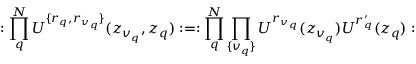Convert formula to latex. <formula><loc_0><loc_0><loc_500><loc_500>\colon \prod _ { q } ^ { N } U ^ { \{ r _ { q } , r _ { v _ { q } } \} } ( z _ { v _ { q } } , z _ { q } ) \colon = \colon \prod _ { q } ^ { N } \prod _ { \{ v _ { q } \} } U ^ { r _ { v _ { q } } } ( z _ { v _ { q } } ) U ^ { r _ { q } ^ { \prime } } ( z _ { q } ) \colon</formula> 